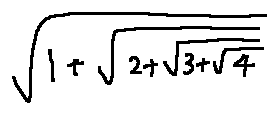<formula> <loc_0><loc_0><loc_500><loc_500>\sqrt { 1 + \sqrt { 2 + \sqrt { 3 + \sqrt { 4 } } } }</formula> 